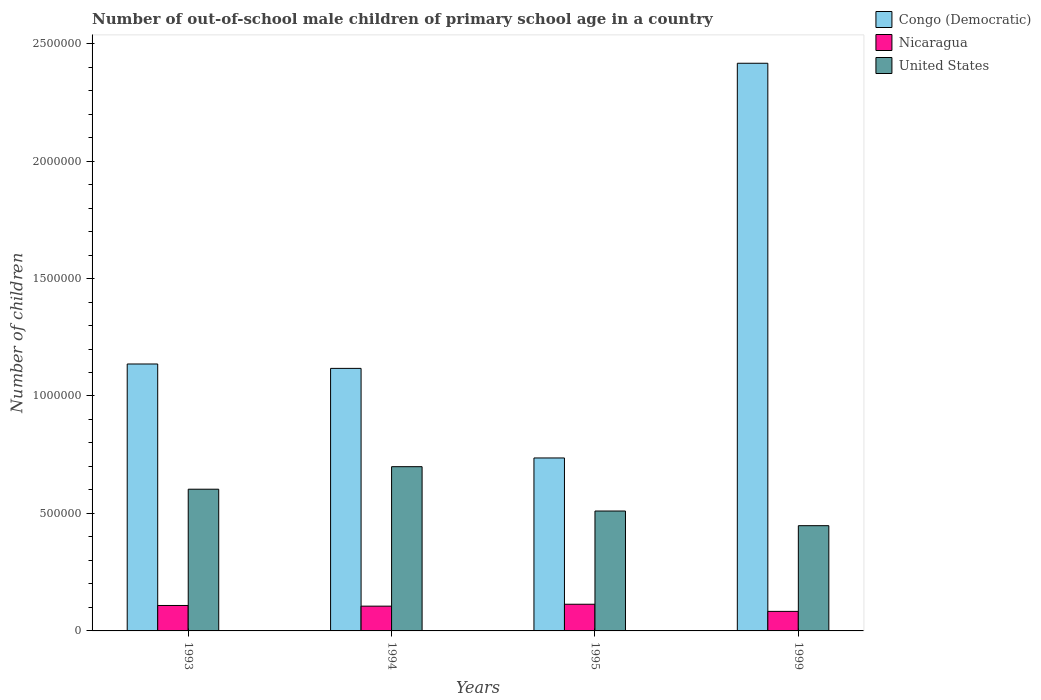How many groups of bars are there?
Provide a succinct answer. 4. Are the number of bars on each tick of the X-axis equal?
Provide a succinct answer. Yes. What is the number of out-of-school male children in Congo (Democratic) in 1995?
Your response must be concise. 7.36e+05. Across all years, what is the maximum number of out-of-school male children in Nicaragua?
Ensure brevity in your answer.  1.14e+05. Across all years, what is the minimum number of out-of-school male children in Congo (Democratic)?
Keep it short and to the point. 7.36e+05. In which year was the number of out-of-school male children in Nicaragua maximum?
Your response must be concise. 1995. What is the total number of out-of-school male children in United States in the graph?
Offer a terse response. 2.26e+06. What is the difference between the number of out-of-school male children in Nicaragua in 1993 and that in 1994?
Provide a succinct answer. 2829. What is the difference between the number of out-of-school male children in Congo (Democratic) in 1993 and the number of out-of-school male children in United States in 1999?
Offer a very short reply. 6.88e+05. What is the average number of out-of-school male children in United States per year?
Your response must be concise. 5.65e+05. In the year 1994, what is the difference between the number of out-of-school male children in Congo (Democratic) and number of out-of-school male children in Nicaragua?
Ensure brevity in your answer.  1.01e+06. In how many years, is the number of out-of-school male children in Nicaragua greater than 1300000?
Offer a very short reply. 0. What is the ratio of the number of out-of-school male children in Congo (Democratic) in 1993 to that in 1999?
Your answer should be very brief. 0.47. What is the difference between the highest and the second highest number of out-of-school male children in Nicaragua?
Keep it short and to the point. 5286. What is the difference between the highest and the lowest number of out-of-school male children in United States?
Provide a succinct answer. 2.51e+05. In how many years, is the number of out-of-school male children in United States greater than the average number of out-of-school male children in United States taken over all years?
Provide a short and direct response. 2. Is the sum of the number of out-of-school male children in Nicaragua in 1993 and 1999 greater than the maximum number of out-of-school male children in United States across all years?
Keep it short and to the point. No. What does the 1st bar from the left in 1994 represents?
Offer a very short reply. Congo (Democratic). What is the difference between two consecutive major ticks on the Y-axis?
Give a very brief answer. 5.00e+05. Are the values on the major ticks of Y-axis written in scientific E-notation?
Provide a succinct answer. No. Does the graph contain grids?
Offer a very short reply. No. How many legend labels are there?
Provide a short and direct response. 3. What is the title of the graph?
Provide a short and direct response. Number of out-of-school male children of primary school age in a country. What is the label or title of the Y-axis?
Provide a succinct answer. Number of children. What is the Number of children of Congo (Democratic) in 1993?
Provide a succinct answer. 1.14e+06. What is the Number of children of Nicaragua in 1993?
Provide a short and direct response. 1.08e+05. What is the Number of children in United States in 1993?
Provide a succinct answer. 6.03e+05. What is the Number of children in Congo (Democratic) in 1994?
Offer a very short reply. 1.12e+06. What is the Number of children in Nicaragua in 1994?
Give a very brief answer. 1.05e+05. What is the Number of children of United States in 1994?
Offer a terse response. 6.99e+05. What is the Number of children in Congo (Democratic) in 1995?
Provide a succinct answer. 7.36e+05. What is the Number of children in Nicaragua in 1995?
Offer a very short reply. 1.14e+05. What is the Number of children of United States in 1995?
Provide a succinct answer. 5.10e+05. What is the Number of children in Congo (Democratic) in 1999?
Ensure brevity in your answer.  2.42e+06. What is the Number of children of Nicaragua in 1999?
Offer a very short reply. 8.32e+04. What is the Number of children in United States in 1999?
Offer a very short reply. 4.48e+05. Across all years, what is the maximum Number of children of Congo (Democratic)?
Ensure brevity in your answer.  2.42e+06. Across all years, what is the maximum Number of children in Nicaragua?
Provide a short and direct response. 1.14e+05. Across all years, what is the maximum Number of children in United States?
Your answer should be compact. 6.99e+05. Across all years, what is the minimum Number of children of Congo (Democratic)?
Keep it short and to the point. 7.36e+05. Across all years, what is the minimum Number of children in Nicaragua?
Ensure brevity in your answer.  8.32e+04. Across all years, what is the minimum Number of children in United States?
Provide a succinct answer. 4.48e+05. What is the total Number of children of Congo (Democratic) in the graph?
Your response must be concise. 5.41e+06. What is the total Number of children in Nicaragua in the graph?
Provide a short and direct response. 4.11e+05. What is the total Number of children of United States in the graph?
Keep it short and to the point. 2.26e+06. What is the difference between the Number of children in Congo (Democratic) in 1993 and that in 1994?
Provide a short and direct response. 1.87e+04. What is the difference between the Number of children in Nicaragua in 1993 and that in 1994?
Give a very brief answer. 2829. What is the difference between the Number of children in United States in 1993 and that in 1994?
Offer a terse response. -9.59e+04. What is the difference between the Number of children in Congo (Democratic) in 1993 and that in 1995?
Make the answer very short. 4.00e+05. What is the difference between the Number of children in Nicaragua in 1993 and that in 1995?
Offer a terse response. -5286. What is the difference between the Number of children of United States in 1993 and that in 1995?
Provide a succinct answer. 9.29e+04. What is the difference between the Number of children in Congo (Democratic) in 1993 and that in 1999?
Your response must be concise. -1.28e+06. What is the difference between the Number of children in Nicaragua in 1993 and that in 1999?
Your answer should be compact. 2.51e+04. What is the difference between the Number of children of United States in 1993 and that in 1999?
Offer a very short reply. 1.55e+05. What is the difference between the Number of children of Congo (Democratic) in 1994 and that in 1995?
Give a very brief answer. 3.81e+05. What is the difference between the Number of children of Nicaragua in 1994 and that in 1995?
Keep it short and to the point. -8115. What is the difference between the Number of children of United States in 1994 and that in 1995?
Provide a short and direct response. 1.89e+05. What is the difference between the Number of children in Congo (Democratic) in 1994 and that in 1999?
Ensure brevity in your answer.  -1.30e+06. What is the difference between the Number of children in Nicaragua in 1994 and that in 1999?
Give a very brief answer. 2.23e+04. What is the difference between the Number of children in United States in 1994 and that in 1999?
Offer a very short reply. 2.51e+05. What is the difference between the Number of children in Congo (Democratic) in 1995 and that in 1999?
Keep it short and to the point. -1.68e+06. What is the difference between the Number of children in Nicaragua in 1995 and that in 1999?
Provide a short and direct response. 3.04e+04. What is the difference between the Number of children in United States in 1995 and that in 1999?
Your answer should be very brief. 6.24e+04. What is the difference between the Number of children in Congo (Democratic) in 1993 and the Number of children in Nicaragua in 1994?
Your response must be concise. 1.03e+06. What is the difference between the Number of children of Congo (Democratic) in 1993 and the Number of children of United States in 1994?
Give a very brief answer. 4.37e+05. What is the difference between the Number of children in Nicaragua in 1993 and the Number of children in United States in 1994?
Your answer should be compact. -5.91e+05. What is the difference between the Number of children in Congo (Democratic) in 1993 and the Number of children in Nicaragua in 1995?
Provide a succinct answer. 1.02e+06. What is the difference between the Number of children in Congo (Democratic) in 1993 and the Number of children in United States in 1995?
Your response must be concise. 6.26e+05. What is the difference between the Number of children of Nicaragua in 1993 and the Number of children of United States in 1995?
Your answer should be very brief. -4.02e+05. What is the difference between the Number of children of Congo (Democratic) in 1993 and the Number of children of Nicaragua in 1999?
Offer a very short reply. 1.05e+06. What is the difference between the Number of children of Congo (Democratic) in 1993 and the Number of children of United States in 1999?
Provide a short and direct response. 6.88e+05. What is the difference between the Number of children in Nicaragua in 1993 and the Number of children in United States in 1999?
Keep it short and to the point. -3.40e+05. What is the difference between the Number of children in Congo (Democratic) in 1994 and the Number of children in Nicaragua in 1995?
Offer a very short reply. 1.00e+06. What is the difference between the Number of children in Congo (Democratic) in 1994 and the Number of children in United States in 1995?
Provide a short and direct response. 6.07e+05. What is the difference between the Number of children in Nicaragua in 1994 and the Number of children in United States in 1995?
Provide a short and direct response. -4.05e+05. What is the difference between the Number of children in Congo (Democratic) in 1994 and the Number of children in Nicaragua in 1999?
Provide a succinct answer. 1.03e+06. What is the difference between the Number of children of Congo (Democratic) in 1994 and the Number of children of United States in 1999?
Provide a succinct answer. 6.70e+05. What is the difference between the Number of children of Nicaragua in 1994 and the Number of children of United States in 1999?
Provide a succinct answer. -3.43e+05. What is the difference between the Number of children in Congo (Democratic) in 1995 and the Number of children in Nicaragua in 1999?
Give a very brief answer. 6.53e+05. What is the difference between the Number of children of Congo (Democratic) in 1995 and the Number of children of United States in 1999?
Your answer should be very brief. 2.88e+05. What is the difference between the Number of children of Nicaragua in 1995 and the Number of children of United States in 1999?
Your answer should be very brief. -3.34e+05. What is the average Number of children of Congo (Democratic) per year?
Provide a short and direct response. 1.35e+06. What is the average Number of children of Nicaragua per year?
Your answer should be very brief. 1.03e+05. What is the average Number of children in United States per year?
Your response must be concise. 5.65e+05. In the year 1993, what is the difference between the Number of children in Congo (Democratic) and Number of children in Nicaragua?
Offer a very short reply. 1.03e+06. In the year 1993, what is the difference between the Number of children of Congo (Democratic) and Number of children of United States?
Give a very brief answer. 5.33e+05. In the year 1993, what is the difference between the Number of children in Nicaragua and Number of children in United States?
Your answer should be compact. -4.95e+05. In the year 1994, what is the difference between the Number of children of Congo (Democratic) and Number of children of Nicaragua?
Provide a succinct answer. 1.01e+06. In the year 1994, what is the difference between the Number of children in Congo (Democratic) and Number of children in United States?
Provide a short and direct response. 4.18e+05. In the year 1994, what is the difference between the Number of children of Nicaragua and Number of children of United States?
Ensure brevity in your answer.  -5.94e+05. In the year 1995, what is the difference between the Number of children in Congo (Democratic) and Number of children in Nicaragua?
Offer a terse response. 6.23e+05. In the year 1995, what is the difference between the Number of children of Congo (Democratic) and Number of children of United States?
Provide a succinct answer. 2.26e+05. In the year 1995, what is the difference between the Number of children of Nicaragua and Number of children of United States?
Your answer should be very brief. -3.97e+05. In the year 1999, what is the difference between the Number of children of Congo (Democratic) and Number of children of Nicaragua?
Your answer should be compact. 2.33e+06. In the year 1999, what is the difference between the Number of children in Congo (Democratic) and Number of children in United States?
Provide a short and direct response. 1.97e+06. In the year 1999, what is the difference between the Number of children of Nicaragua and Number of children of United States?
Your response must be concise. -3.65e+05. What is the ratio of the Number of children in Congo (Democratic) in 1993 to that in 1994?
Your response must be concise. 1.02. What is the ratio of the Number of children of Nicaragua in 1993 to that in 1994?
Ensure brevity in your answer.  1.03. What is the ratio of the Number of children in United States in 1993 to that in 1994?
Make the answer very short. 0.86. What is the ratio of the Number of children of Congo (Democratic) in 1993 to that in 1995?
Your answer should be compact. 1.54. What is the ratio of the Number of children of Nicaragua in 1993 to that in 1995?
Provide a succinct answer. 0.95. What is the ratio of the Number of children of United States in 1993 to that in 1995?
Provide a short and direct response. 1.18. What is the ratio of the Number of children in Congo (Democratic) in 1993 to that in 1999?
Give a very brief answer. 0.47. What is the ratio of the Number of children in Nicaragua in 1993 to that in 1999?
Provide a succinct answer. 1.3. What is the ratio of the Number of children of United States in 1993 to that in 1999?
Offer a terse response. 1.35. What is the ratio of the Number of children in Congo (Democratic) in 1994 to that in 1995?
Your response must be concise. 1.52. What is the ratio of the Number of children of Nicaragua in 1994 to that in 1995?
Provide a succinct answer. 0.93. What is the ratio of the Number of children in United States in 1994 to that in 1995?
Give a very brief answer. 1.37. What is the ratio of the Number of children in Congo (Democratic) in 1994 to that in 1999?
Your answer should be compact. 0.46. What is the ratio of the Number of children of Nicaragua in 1994 to that in 1999?
Offer a very short reply. 1.27. What is the ratio of the Number of children of United States in 1994 to that in 1999?
Offer a terse response. 1.56. What is the ratio of the Number of children of Congo (Democratic) in 1995 to that in 1999?
Ensure brevity in your answer.  0.3. What is the ratio of the Number of children of Nicaragua in 1995 to that in 1999?
Your response must be concise. 1.37. What is the ratio of the Number of children in United States in 1995 to that in 1999?
Provide a succinct answer. 1.14. What is the difference between the highest and the second highest Number of children in Congo (Democratic)?
Provide a short and direct response. 1.28e+06. What is the difference between the highest and the second highest Number of children of Nicaragua?
Give a very brief answer. 5286. What is the difference between the highest and the second highest Number of children in United States?
Keep it short and to the point. 9.59e+04. What is the difference between the highest and the lowest Number of children of Congo (Democratic)?
Provide a succinct answer. 1.68e+06. What is the difference between the highest and the lowest Number of children in Nicaragua?
Offer a terse response. 3.04e+04. What is the difference between the highest and the lowest Number of children of United States?
Provide a succinct answer. 2.51e+05. 